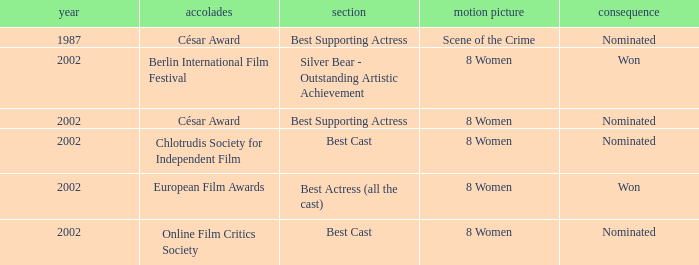In what year was the movie 8 women up for a César Award? 2002.0. 